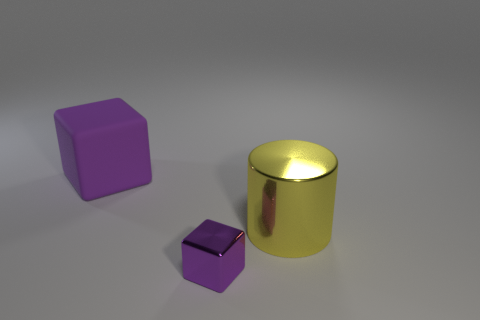Is the color of the metal cube the same as the large rubber cube?
Offer a very short reply. Yes. There is a large thing that is the same color as the tiny cube; what material is it?
Provide a succinct answer. Rubber. The tiny object is what color?
Provide a short and direct response. Purple. What is the color of the cube that is made of the same material as the cylinder?
Your response must be concise. Purple. There is a cube left of the metal object that is in front of the yellow metallic object; what size is it?
Offer a very short reply. Large. Do the object behind the cylinder and the tiny block have the same size?
Keep it short and to the point. No. How many other metallic blocks are the same color as the tiny metallic block?
Offer a terse response. 0. Is there anything else that has the same size as the purple rubber block?
Keep it short and to the point. Yes. The other object that is the same shape as the large matte thing is what size?
Offer a terse response. Small. Is the number of small metallic objects right of the yellow cylinder greater than the number of purple rubber blocks in front of the matte object?
Provide a succinct answer. No. 